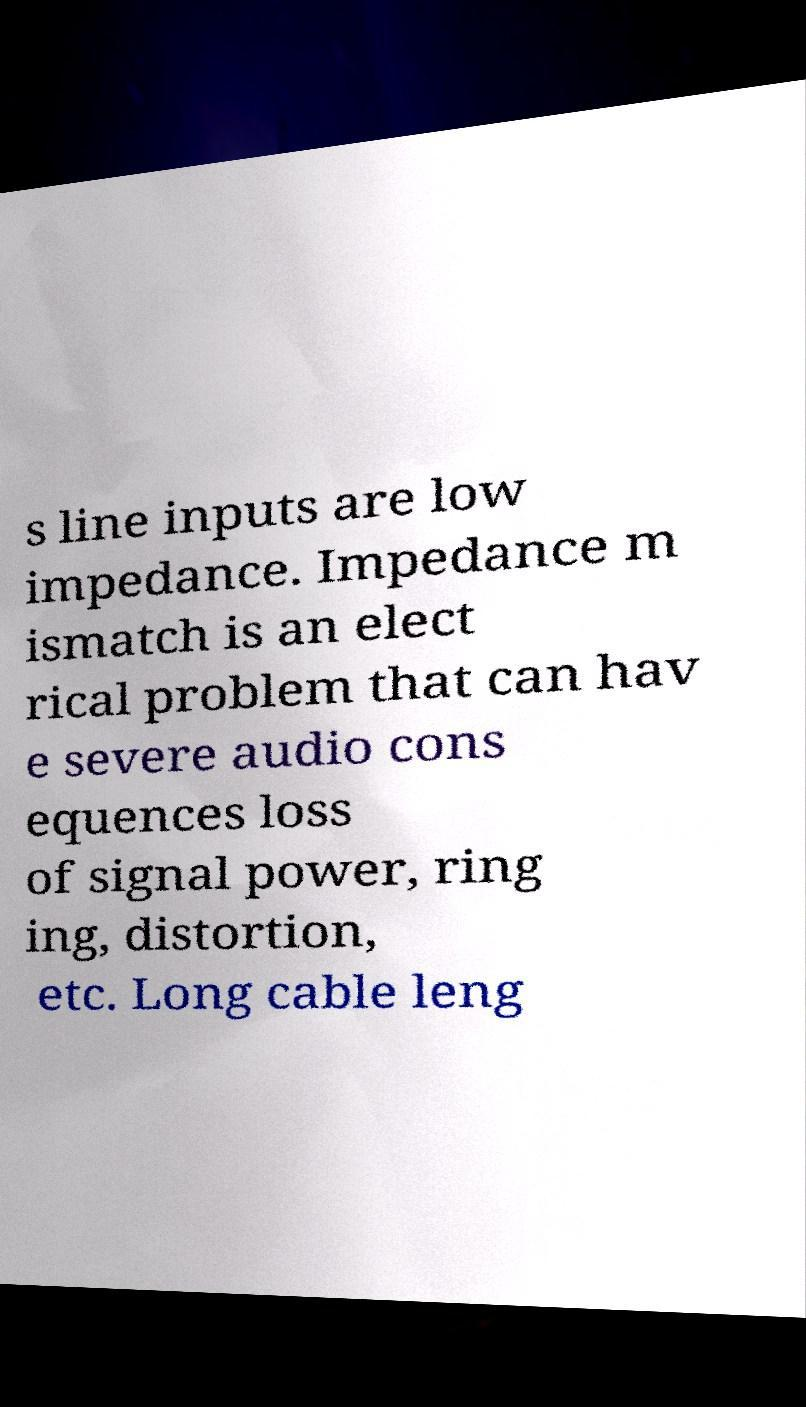Could you assist in decoding the text presented in this image and type it out clearly? s line inputs are low impedance. Impedance m ismatch is an elect rical problem that can hav e severe audio cons equences loss of signal power, ring ing, distortion, etc. Long cable leng 